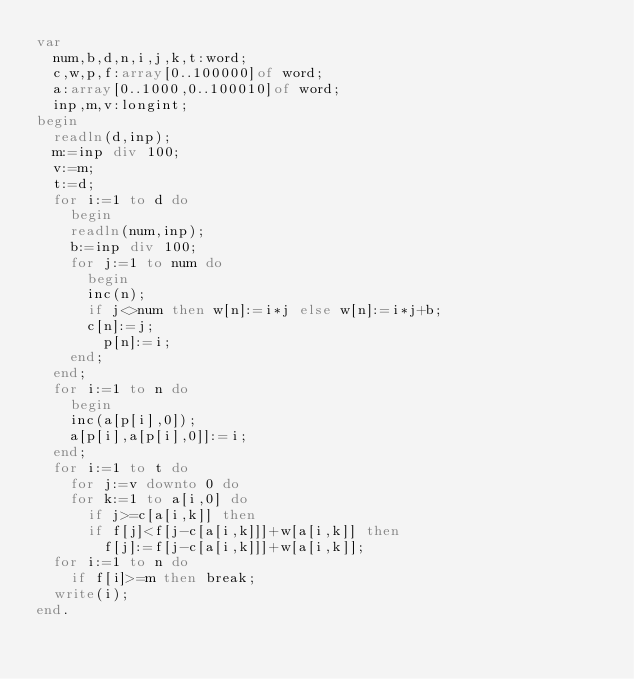Convert code to text. <code><loc_0><loc_0><loc_500><loc_500><_Pascal_>var
  num,b,d,n,i,j,k,t:word;
  c,w,p,f:array[0..100000]of word;
  a:array[0..1000,0..100010]of word; 
  inp,m,v:longint;
begin
  readln(d,inp);
  m:=inp div 100;
  v:=m;
  t:=d;
  for i:=1 to d do
    begin
	  readln(num,inp);
	  b:=inp div 100;
	  for j:=1 to num do
	    begin
		  inc(n);
		  if j<>num then w[n]:=i*j else w[n]:=i*j+b;
		  c[n]:=j;
	      p[n]:=i;
		end;
	end;
  for i:=1 to n do
    begin
	  inc(a[p[i],0]);
	  a[p[i],a[p[i],0]]:=i;
	end;
  for i:=1 to t do
    for j:=v downto 0 do
	  for k:=1 to a[i,0] do
	    if j>=c[a[i,k]] then
		  if f[j]<f[j-c[a[i,k]]]+w[a[i,k]] then
		    f[j]:=f[j-c[a[i,k]]]+w[a[i,k]];
  for i:=1 to n do
    if f[i]>=m then break;
  write(i);
end.</code> 